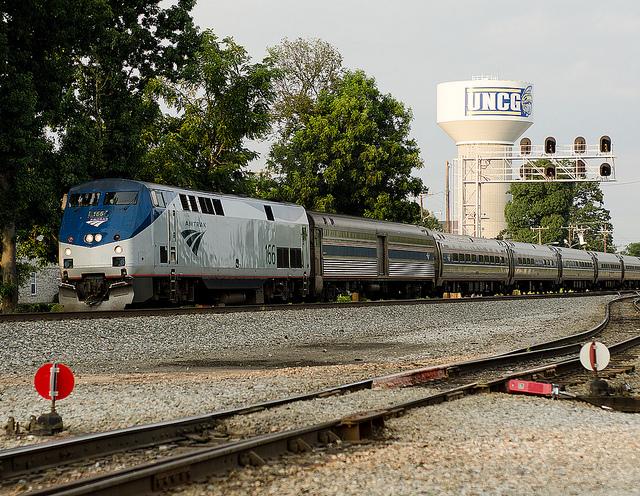What letters are on the tower?
Concise answer only. Uncg. How many windows are on the train?
Write a very short answer. 7. Is this a colorful train?
Write a very short answer. No. How many trains are in the picture?
Give a very brief answer. 1. What color is the sign to the far left of the photo?
Keep it brief. Red. Where are the cars?
Short answer required. On tracks. Should cars stop before the sign right now?
Keep it brief. Yes. What kind of building is the silver one next to the train?
Answer briefly. Water tower. Where is this train going?
Short answer required. West. What color covers the most area of the train cars?
Keep it brief. Silver. Are there power lines visible?
Concise answer only. No. Is the train likely in the United States?
Concise answer only. Yes. Is this a passenger train?
Short answer required. Yes. How fast is the train going?
Be succinct. 0. 